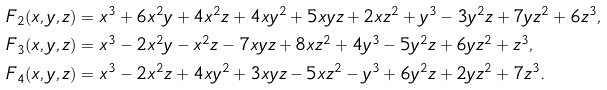Convert formula to latex. <formula><loc_0><loc_0><loc_500><loc_500>F _ { 2 } ( x , y , z ) & = x ^ { 3 } + 6 x ^ { 2 } y + 4 x ^ { 2 } z + 4 x y ^ { 2 } + 5 x y z + 2 x z ^ { 2 } + y ^ { 3 } - 3 y ^ { 2 } z + 7 y z ^ { 2 } + 6 z ^ { 3 } , \\ F _ { 3 } ( x , y , z ) & = x ^ { 3 } - 2 x ^ { 2 } y - x ^ { 2 } z - 7 x y z + 8 x z ^ { 2 } + 4 y ^ { 3 } - 5 y ^ { 2 } z + 6 y z ^ { 2 } + z ^ { 3 } , \\ F _ { 4 } ( x , y , z ) & = x ^ { 3 } - 2 x ^ { 2 } z + 4 x y ^ { 2 } + 3 x y z - 5 x z ^ { 2 } - y ^ { 3 } + 6 y ^ { 2 } z + 2 y z ^ { 2 } + 7 z ^ { 3 } .</formula> 